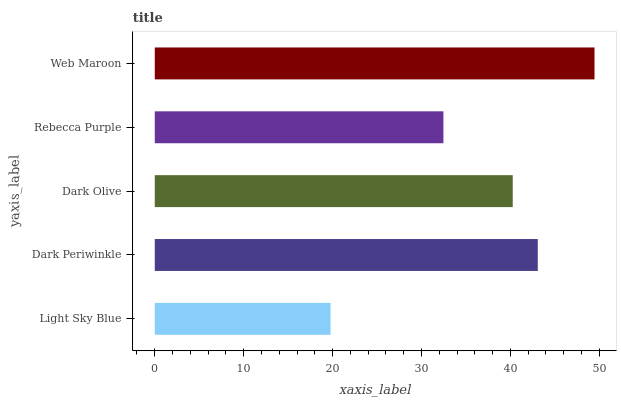Is Light Sky Blue the minimum?
Answer yes or no. Yes. Is Web Maroon the maximum?
Answer yes or no. Yes. Is Dark Periwinkle the minimum?
Answer yes or no. No. Is Dark Periwinkle the maximum?
Answer yes or no. No. Is Dark Periwinkle greater than Light Sky Blue?
Answer yes or no. Yes. Is Light Sky Blue less than Dark Periwinkle?
Answer yes or no. Yes. Is Light Sky Blue greater than Dark Periwinkle?
Answer yes or no. No. Is Dark Periwinkle less than Light Sky Blue?
Answer yes or no. No. Is Dark Olive the high median?
Answer yes or no. Yes. Is Dark Olive the low median?
Answer yes or no. Yes. Is Web Maroon the high median?
Answer yes or no. No. Is Light Sky Blue the low median?
Answer yes or no. No. 